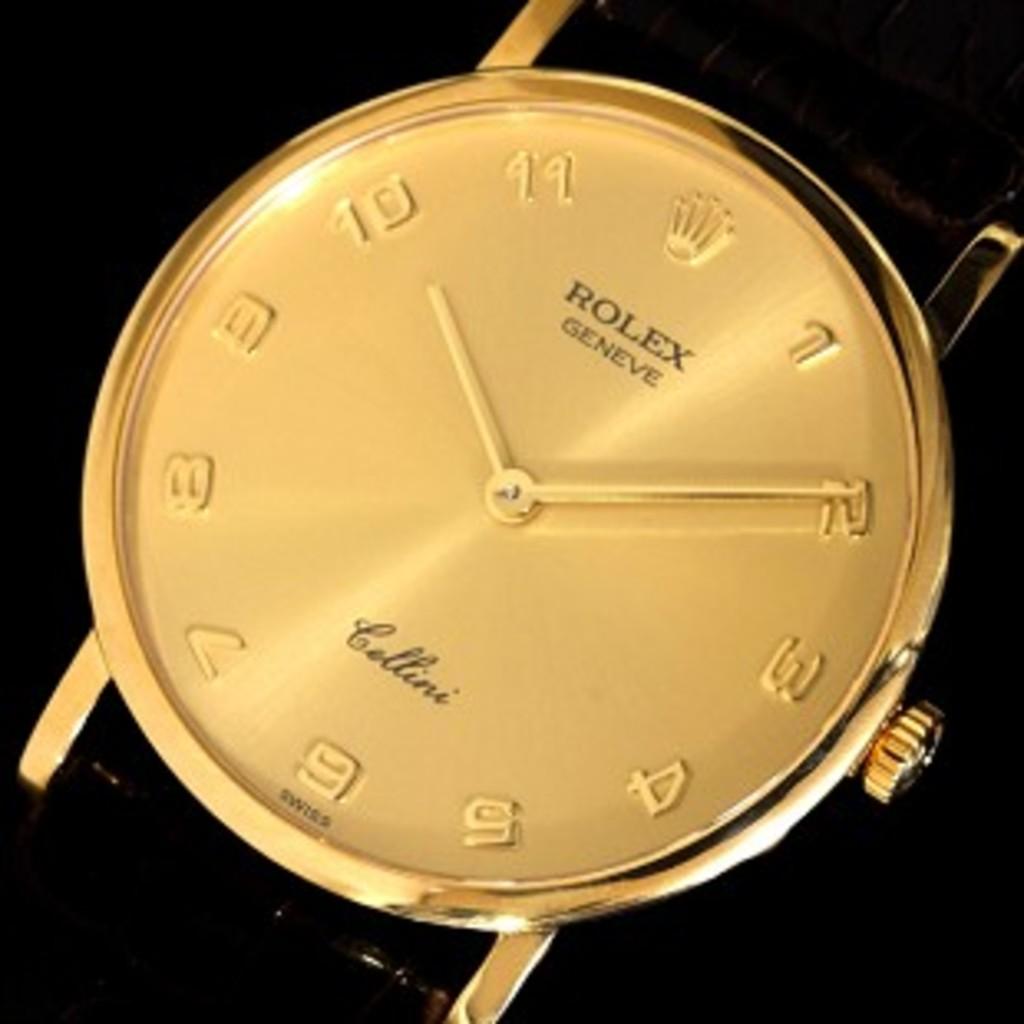What time is on the watch?
Provide a succinct answer. 10:10. What brand of watch is this?
Offer a terse response. Rolex. 